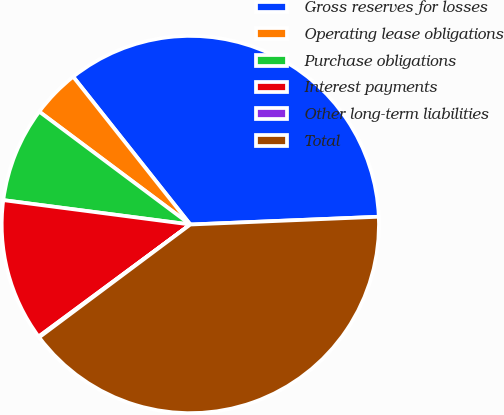Convert chart to OTSL. <chart><loc_0><loc_0><loc_500><loc_500><pie_chart><fcel>Gross reserves for losses<fcel>Operating lease obligations<fcel>Purchase obligations<fcel>Interest payments<fcel>Other long-term liabilities<fcel>Total<nl><fcel>35.01%<fcel>4.12%<fcel>8.15%<fcel>12.19%<fcel>0.08%<fcel>40.45%<nl></chart> 